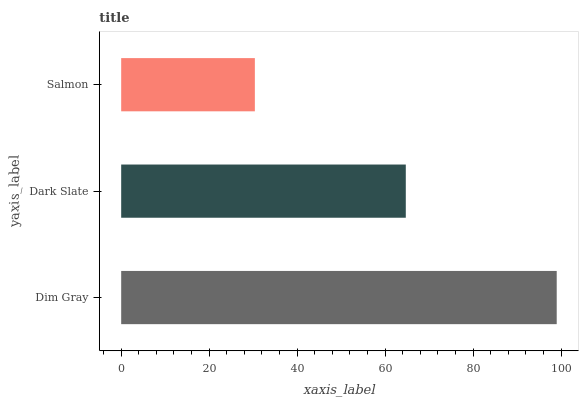Is Salmon the minimum?
Answer yes or no. Yes. Is Dim Gray the maximum?
Answer yes or no. Yes. Is Dark Slate the minimum?
Answer yes or no. No. Is Dark Slate the maximum?
Answer yes or no. No. Is Dim Gray greater than Dark Slate?
Answer yes or no. Yes. Is Dark Slate less than Dim Gray?
Answer yes or no. Yes. Is Dark Slate greater than Dim Gray?
Answer yes or no. No. Is Dim Gray less than Dark Slate?
Answer yes or no. No. Is Dark Slate the high median?
Answer yes or no. Yes. Is Dark Slate the low median?
Answer yes or no. Yes. Is Dim Gray the high median?
Answer yes or no. No. Is Salmon the low median?
Answer yes or no. No. 